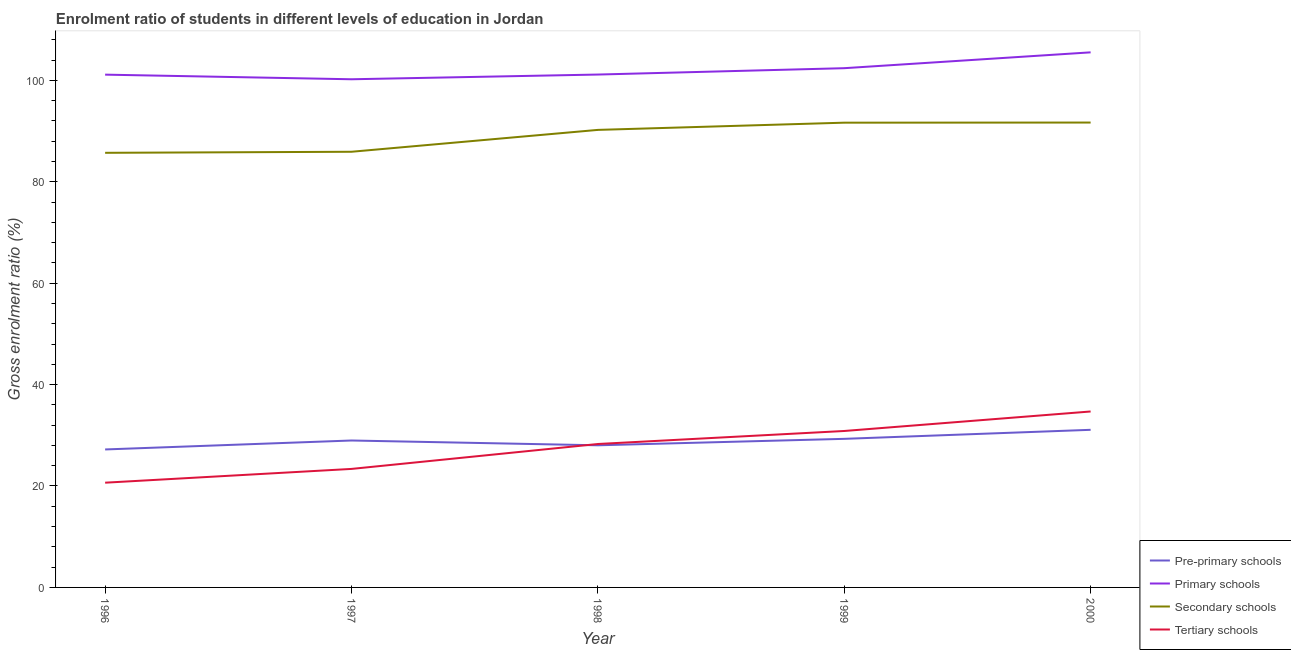How many different coloured lines are there?
Your response must be concise. 4. What is the gross enrolment ratio in tertiary schools in 1999?
Offer a terse response. 30.85. Across all years, what is the maximum gross enrolment ratio in primary schools?
Ensure brevity in your answer.  105.51. Across all years, what is the minimum gross enrolment ratio in tertiary schools?
Ensure brevity in your answer.  20.65. What is the total gross enrolment ratio in pre-primary schools in the graph?
Your answer should be compact. 144.58. What is the difference between the gross enrolment ratio in secondary schools in 1997 and that in 1999?
Give a very brief answer. -5.74. What is the difference between the gross enrolment ratio in primary schools in 1997 and the gross enrolment ratio in tertiary schools in 1998?
Your response must be concise. 71.92. What is the average gross enrolment ratio in primary schools per year?
Your response must be concise. 102.07. In the year 1996, what is the difference between the gross enrolment ratio in tertiary schools and gross enrolment ratio in primary schools?
Offer a very short reply. -80.46. What is the ratio of the gross enrolment ratio in tertiary schools in 1996 to that in 1997?
Your answer should be compact. 0.88. Is the difference between the gross enrolment ratio in tertiary schools in 1998 and 2000 greater than the difference between the gross enrolment ratio in pre-primary schools in 1998 and 2000?
Your response must be concise. No. What is the difference between the highest and the second highest gross enrolment ratio in tertiary schools?
Offer a very short reply. 3.85. What is the difference between the highest and the lowest gross enrolment ratio in pre-primary schools?
Provide a succinct answer. 3.87. Is the sum of the gross enrolment ratio in primary schools in 1998 and 2000 greater than the maximum gross enrolment ratio in tertiary schools across all years?
Your answer should be very brief. Yes. Is it the case that in every year, the sum of the gross enrolment ratio in pre-primary schools and gross enrolment ratio in primary schools is greater than the gross enrolment ratio in secondary schools?
Give a very brief answer. Yes. Is the gross enrolment ratio in primary schools strictly less than the gross enrolment ratio in secondary schools over the years?
Make the answer very short. No. How many lines are there?
Give a very brief answer. 4. How many years are there in the graph?
Provide a short and direct response. 5. How many legend labels are there?
Your answer should be very brief. 4. What is the title of the graph?
Your answer should be very brief. Enrolment ratio of students in different levels of education in Jordan. Does "Primary schools" appear as one of the legend labels in the graph?
Ensure brevity in your answer.  Yes. What is the Gross enrolment ratio (%) of Pre-primary schools in 1996?
Provide a short and direct response. 27.21. What is the Gross enrolment ratio (%) of Primary schools in 1996?
Keep it short and to the point. 101.11. What is the Gross enrolment ratio (%) in Secondary schools in 1996?
Ensure brevity in your answer.  85.7. What is the Gross enrolment ratio (%) of Tertiary schools in 1996?
Your answer should be very brief. 20.65. What is the Gross enrolment ratio (%) in Pre-primary schools in 1997?
Offer a very short reply. 28.97. What is the Gross enrolment ratio (%) of Primary schools in 1997?
Your answer should be compact. 100.2. What is the Gross enrolment ratio (%) of Secondary schools in 1997?
Make the answer very short. 85.91. What is the Gross enrolment ratio (%) of Tertiary schools in 1997?
Provide a succinct answer. 23.37. What is the Gross enrolment ratio (%) of Pre-primary schools in 1998?
Your answer should be compact. 28.03. What is the Gross enrolment ratio (%) of Primary schools in 1998?
Give a very brief answer. 101.13. What is the Gross enrolment ratio (%) of Secondary schools in 1998?
Your answer should be very brief. 90.22. What is the Gross enrolment ratio (%) of Tertiary schools in 1998?
Give a very brief answer. 28.28. What is the Gross enrolment ratio (%) of Pre-primary schools in 1999?
Your answer should be very brief. 29.3. What is the Gross enrolment ratio (%) of Primary schools in 1999?
Offer a terse response. 102.39. What is the Gross enrolment ratio (%) in Secondary schools in 1999?
Your answer should be very brief. 91.64. What is the Gross enrolment ratio (%) of Tertiary schools in 1999?
Your answer should be very brief. 30.85. What is the Gross enrolment ratio (%) in Pre-primary schools in 2000?
Your answer should be very brief. 31.08. What is the Gross enrolment ratio (%) in Primary schools in 2000?
Give a very brief answer. 105.51. What is the Gross enrolment ratio (%) in Secondary schools in 2000?
Your response must be concise. 91.67. What is the Gross enrolment ratio (%) in Tertiary schools in 2000?
Provide a short and direct response. 34.69. Across all years, what is the maximum Gross enrolment ratio (%) in Pre-primary schools?
Offer a very short reply. 31.08. Across all years, what is the maximum Gross enrolment ratio (%) of Primary schools?
Offer a very short reply. 105.51. Across all years, what is the maximum Gross enrolment ratio (%) in Secondary schools?
Give a very brief answer. 91.67. Across all years, what is the maximum Gross enrolment ratio (%) of Tertiary schools?
Your answer should be compact. 34.69. Across all years, what is the minimum Gross enrolment ratio (%) of Pre-primary schools?
Ensure brevity in your answer.  27.21. Across all years, what is the minimum Gross enrolment ratio (%) in Primary schools?
Offer a very short reply. 100.2. Across all years, what is the minimum Gross enrolment ratio (%) of Secondary schools?
Your answer should be very brief. 85.7. Across all years, what is the minimum Gross enrolment ratio (%) in Tertiary schools?
Make the answer very short. 20.65. What is the total Gross enrolment ratio (%) of Pre-primary schools in the graph?
Your answer should be compact. 144.58. What is the total Gross enrolment ratio (%) of Primary schools in the graph?
Ensure brevity in your answer.  510.35. What is the total Gross enrolment ratio (%) in Secondary schools in the graph?
Offer a terse response. 445.14. What is the total Gross enrolment ratio (%) of Tertiary schools in the graph?
Offer a terse response. 137.84. What is the difference between the Gross enrolment ratio (%) of Pre-primary schools in 1996 and that in 1997?
Give a very brief answer. -1.77. What is the difference between the Gross enrolment ratio (%) in Primary schools in 1996 and that in 1997?
Provide a succinct answer. 0.91. What is the difference between the Gross enrolment ratio (%) in Secondary schools in 1996 and that in 1997?
Offer a terse response. -0.21. What is the difference between the Gross enrolment ratio (%) of Tertiary schools in 1996 and that in 1997?
Make the answer very short. -2.72. What is the difference between the Gross enrolment ratio (%) of Pre-primary schools in 1996 and that in 1998?
Ensure brevity in your answer.  -0.82. What is the difference between the Gross enrolment ratio (%) in Primary schools in 1996 and that in 1998?
Offer a very short reply. -0.02. What is the difference between the Gross enrolment ratio (%) of Secondary schools in 1996 and that in 1998?
Keep it short and to the point. -4.52. What is the difference between the Gross enrolment ratio (%) in Tertiary schools in 1996 and that in 1998?
Provide a succinct answer. -7.63. What is the difference between the Gross enrolment ratio (%) of Pre-primary schools in 1996 and that in 1999?
Make the answer very short. -2.09. What is the difference between the Gross enrolment ratio (%) of Primary schools in 1996 and that in 1999?
Keep it short and to the point. -1.27. What is the difference between the Gross enrolment ratio (%) in Secondary schools in 1996 and that in 1999?
Offer a very short reply. -5.94. What is the difference between the Gross enrolment ratio (%) in Tertiary schools in 1996 and that in 1999?
Keep it short and to the point. -10.2. What is the difference between the Gross enrolment ratio (%) in Pre-primary schools in 1996 and that in 2000?
Your answer should be compact. -3.87. What is the difference between the Gross enrolment ratio (%) in Primary schools in 1996 and that in 2000?
Offer a very short reply. -4.4. What is the difference between the Gross enrolment ratio (%) in Secondary schools in 1996 and that in 2000?
Provide a short and direct response. -5.97. What is the difference between the Gross enrolment ratio (%) in Tertiary schools in 1996 and that in 2000?
Keep it short and to the point. -14.04. What is the difference between the Gross enrolment ratio (%) in Pre-primary schools in 1997 and that in 1998?
Your answer should be very brief. 0.95. What is the difference between the Gross enrolment ratio (%) in Primary schools in 1997 and that in 1998?
Provide a short and direct response. -0.93. What is the difference between the Gross enrolment ratio (%) in Secondary schools in 1997 and that in 1998?
Ensure brevity in your answer.  -4.31. What is the difference between the Gross enrolment ratio (%) in Tertiary schools in 1997 and that in 1998?
Your answer should be very brief. -4.91. What is the difference between the Gross enrolment ratio (%) in Pre-primary schools in 1997 and that in 1999?
Provide a short and direct response. -0.32. What is the difference between the Gross enrolment ratio (%) of Primary schools in 1997 and that in 1999?
Your answer should be very brief. -2.18. What is the difference between the Gross enrolment ratio (%) in Secondary schools in 1997 and that in 1999?
Provide a succinct answer. -5.74. What is the difference between the Gross enrolment ratio (%) of Tertiary schools in 1997 and that in 1999?
Keep it short and to the point. -7.48. What is the difference between the Gross enrolment ratio (%) of Pre-primary schools in 1997 and that in 2000?
Make the answer very short. -2.11. What is the difference between the Gross enrolment ratio (%) of Primary schools in 1997 and that in 2000?
Give a very brief answer. -5.31. What is the difference between the Gross enrolment ratio (%) in Secondary schools in 1997 and that in 2000?
Your response must be concise. -5.76. What is the difference between the Gross enrolment ratio (%) of Tertiary schools in 1997 and that in 2000?
Your answer should be very brief. -11.32. What is the difference between the Gross enrolment ratio (%) of Pre-primary schools in 1998 and that in 1999?
Your answer should be compact. -1.27. What is the difference between the Gross enrolment ratio (%) of Primary schools in 1998 and that in 1999?
Keep it short and to the point. -1.25. What is the difference between the Gross enrolment ratio (%) of Secondary schools in 1998 and that in 1999?
Your response must be concise. -1.42. What is the difference between the Gross enrolment ratio (%) of Tertiary schools in 1998 and that in 1999?
Make the answer very short. -2.57. What is the difference between the Gross enrolment ratio (%) in Pre-primary schools in 1998 and that in 2000?
Ensure brevity in your answer.  -3.05. What is the difference between the Gross enrolment ratio (%) of Primary schools in 1998 and that in 2000?
Give a very brief answer. -4.38. What is the difference between the Gross enrolment ratio (%) in Secondary schools in 1998 and that in 2000?
Your answer should be very brief. -1.45. What is the difference between the Gross enrolment ratio (%) in Tertiary schools in 1998 and that in 2000?
Your answer should be very brief. -6.41. What is the difference between the Gross enrolment ratio (%) of Pre-primary schools in 1999 and that in 2000?
Make the answer very short. -1.78. What is the difference between the Gross enrolment ratio (%) in Primary schools in 1999 and that in 2000?
Give a very brief answer. -3.12. What is the difference between the Gross enrolment ratio (%) in Secondary schools in 1999 and that in 2000?
Keep it short and to the point. -0.02. What is the difference between the Gross enrolment ratio (%) in Tertiary schools in 1999 and that in 2000?
Make the answer very short. -3.85. What is the difference between the Gross enrolment ratio (%) of Pre-primary schools in 1996 and the Gross enrolment ratio (%) of Primary schools in 1997?
Provide a short and direct response. -73. What is the difference between the Gross enrolment ratio (%) in Pre-primary schools in 1996 and the Gross enrolment ratio (%) in Secondary schools in 1997?
Your response must be concise. -58.7. What is the difference between the Gross enrolment ratio (%) in Pre-primary schools in 1996 and the Gross enrolment ratio (%) in Tertiary schools in 1997?
Provide a short and direct response. 3.84. What is the difference between the Gross enrolment ratio (%) in Primary schools in 1996 and the Gross enrolment ratio (%) in Secondary schools in 1997?
Your answer should be compact. 15.21. What is the difference between the Gross enrolment ratio (%) of Primary schools in 1996 and the Gross enrolment ratio (%) of Tertiary schools in 1997?
Your response must be concise. 77.74. What is the difference between the Gross enrolment ratio (%) in Secondary schools in 1996 and the Gross enrolment ratio (%) in Tertiary schools in 1997?
Offer a very short reply. 62.33. What is the difference between the Gross enrolment ratio (%) in Pre-primary schools in 1996 and the Gross enrolment ratio (%) in Primary schools in 1998?
Your response must be concise. -73.93. What is the difference between the Gross enrolment ratio (%) in Pre-primary schools in 1996 and the Gross enrolment ratio (%) in Secondary schools in 1998?
Ensure brevity in your answer.  -63.01. What is the difference between the Gross enrolment ratio (%) in Pre-primary schools in 1996 and the Gross enrolment ratio (%) in Tertiary schools in 1998?
Your answer should be very brief. -1.07. What is the difference between the Gross enrolment ratio (%) of Primary schools in 1996 and the Gross enrolment ratio (%) of Secondary schools in 1998?
Your answer should be compact. 10.89. What is the difference between the Gross enrolment ratio (%) in Primary schools in 1996 and the Gross enrolment ratio (%) in Tertiary schools in 1998?
Keep it short and to the point. 72.83. What is the difference between the Gross enrolment ratio (%) of Secondary schools in 1996 and the Gross enrolment ratio (%) of Tertiary schools in 1998?
Your response must be concise. 57.42. What is the difference between the Gross enrolment ratio (%) in Pre-primary schools in 1996 and the Gross enrolment ratio (%) in Primary schools in 1999?
Provide a short and direct response. -75.18. What is the difference between the Gross enrolment ratio (%) of Pre-primary schools in 1996 and the Gross enrolment ratio (%) of Secondary schools in 1999?
Ensure brevity in your answer.  -64.44. What is the difference between the Gross enrolment ratio (%) of Pre-primary schools in 1996 and the Gross enrolment ratio (%) of Tertiary schools in 1999?
Keep it short and to the point. -3.64. What is the difference between the Gross enrolment ratio (%) of Primary schools in 1996 and the Gross enrolment ratio (%) of Secondary schools in 1999?
Give a very brief answer. 9.47. What is the difference between the Gross enrolment ratio (%) in Primary schools in 1996 and the Gross enrolment ratio (%) in Tertiary schools in 1999?
Keep it short and to the point. 70.27. What is the difference between the Gross enrolment ratio (%) in Secondary schools in 1996 and the Gross enrolment ratio (%) in Tertiary schools in 1999?
Offer a very short reply. 54.85. What is the difference between the Gross enrolment ratio (%) in Pre-primary schools in 1996 and the Gross enrolment ratio (%) in Primary schools in 2000?
Make the answer very short. -78.3. What is the difference between the Gross enrolment ratio (%) in Pre-primary schools in 1996 and the Gross enrolment ratio (%) in Secondary schools in 2000?
Give a very brief answer. -64.46. What is the difference between the Gross enrolment ratio (%) of Pre-primary schools in 1996 and the Gross enrolment ratio (%) of Tertiary schools in 2000?
Provide a succinct answer. -7.49. What is the difference between the Gross enrolment ratio (%) in Primary schools in 1996 and the Gross enrolment ratio (%) in Secondary schools in 2000?
Make the answer very short. 9.45. What is the difference between the Gross enrolment ratio (%) in Primary schools in 1996 and the Gross enrolment ratio (%) in Tertiary schools in 2000?
Offer a very short reply. 66.42. What is the difference between the Gross enrolment ratio (%) of Secondary schools in 1996 and the Gross enrolment ratio (%) of Tertiary schools in 2000?
Give a very brief answer. 51.01. What is the difference between the Gross enrolment ratio (%) in Pre-primary schools in 1997 and the Gross enrolment ratio (%) in Primary schools in 1998?
Ensure brevity in your answer.  -72.16. What is the difference between the Gross enrolment ratio (%) of Pre-primary schools in 1997 and the Gross enrolment ratio (%) of Secondary schools in 1998?
Provide a short and direct response. -61.25. What is the difference between the Gross enrolment ratio (%) in Pre-primary schools in 1997 and the Gross enrolment ratio (%) in Tertiary schools in 1998?
Make the answer very short. 0.69. What is the difference between the Gross enrolment ratio (%) of Primary schools in 1997 and the Gross enrolment ratio (%) of Secondary schools in 1998?
Your answer should be compact. 9.98. What is the difference between the Gross enrolment ratio (%) in Primary schools in 1997 and the Gross enrolment ratio (%) in Tertiary schools in 1998?
Your response must be concise. 71.92. What is the difference between the Gross enrolment ratio (%) of Secondary schools in 1997 and the Gross enrolment ratio (%) of Tertiary schools in 1998?
Provide a succinct answer. 57.63. What is the difference between the Gross enrolment ratio (%) of Pre-primary schools in 1997 and the Gross enrolment ratio (%) of Primary schools in 1999?
Make the answer very short. -73.41. What is the difference between the Gross enrolment ratio (%) in Pre-primary schools in 1997 and the Gross enrolment ratio (%) in Secondary schools in 1999?
Make the answer very short. -62.67. What is the difference between the Gross enrolment ratio (%) in Pre-primary schools in 1997 and the Gross enrolment ratio (%) in Tertiary schools in 1999?
Your answer should be very brief. -1.87. What is the difference between the Gross enrolment ratio (%) in Primary schools in 1997 and the Gross enrolment ratio (%) in Secondary schools in 1999?
Offer a terse response. 8.56. What is the difference between the Gross enrolment ratio (%) in Primary schools in 1997 and the Gross enrolment ratio (%) in Tertiary schools in 1999?
Offer a terse response. 69.35. What is the difference between the Gross enrolment ratio (%) in Secondary schools in 1997 and the Gross enrolment ratio (%) in Tertiary schools in 1999?
Offer a terse response. 55.06. What is the difference between the Gross enrolment ratio (%) of Pre-primary schools in 1997 and the Gross enrolment ratio (%) of Primary schools in 2000?
Ensure brevity in your answer.  -76.54. What is the difference between the Gross enrolment ratio (%) of Pre-primary schools in 1997 and the Gross enrolment ratio (%) of Secondary schools in 2000?
Keep it short and to the point. -62.69. What is the difference between the Gross enrolment ratio (%) in Pre-primary schools in 1997 and the Gross enrolment ratio (%) in Tertiary schools in 2000?
Make the answer very short. -5.72. What is the difference between the Gross enrolment ratio (%) in Primary schools in 1997 and the Gross enrolment ratio (%) in Secondary schools in 2000?
Your response must be concise. 8.54. What is the difference between the Gross enrolment ratio (%) in Primary schools in 1997 and the Gross enrolment ratio (%) in Tertiary schools in 2000?
Provide a short and direct response. 65.51. What is the difference between the Gross enrolment ratio (%) of Secondary schools in 1997 and the Gross enrolment ratio (%) of Tertiary schools in 2000?
Offer a terse response. 51.21. What is the difference between the Gross enrolment ratio (%) of Pre-primary schools in 1998 and the Gross enrolment ratio (%) of Primary schools in 1999?
Offer a very short reply. -74.36. What is the difference between the Gross enrolment ratio (%) of Pre-primary schools in 1998 and the Gross enrolment ratio (%) of Secondary schools in 1999?
Your response must be concise. -63.62. What is the difference between the Gross enrolment ratio (%) of Pre-primary schools in 1998 and the Gross enrolment ratio (%) of Tertiary schools in 1999?
Keep it short and to the point. -2.82. What is the difference between the Gross enrolment ratio (%) in Primary schools in 1998 and the Gross enrolment ratio (%) in Secondary schools in 1999?
Offer a terse response. 9.49. What is the difference between the Gross enrolment ratio (%) in Primary schools in 1998 and the Gross enrolment ratio (%) in Tertiary schools in 1999?
Keep it short and to the point. 70.29. What is the difference between the Gross enrolment ratio (%) of Secondary schools in 1998 and the Gross enrolment ratio (%) of Tertiary schools in 1999?
Ensure brevity in your answer.  59.37. What is the difference between the Gross enrolment ratio (%) in Pre-primary schools in 1998 and the Gross enrolment ratio (%) in Primary schools in 2000?
Your answer should be very brief. -77.48. What is the difference between the Gross enrolment ratio (%) of Pre-primary schools in 1998 and the Gross enrolment ratio (%) of Secondary schools in 2000?
Ensure brevity in your answer.  -63.64. What is the difference between the Gross enrolment ratio (%) of Pre-primary schools in 1998 and the Gross enrolment ratio (%) of Tertiary schools in 2000?
Your answer should be compact. -6.67. What is the difference between the Gross enrolment ratio (%) in Primary schools in 1998 and the Gross enrolment ratio (%) in Secondary schools in 2000?
Ensure brevity in your answer.  9.47. What is the difference between the Gross enrolment ratio (%) in Primary schools in 1998 and the Gross enrolment ratio (%) in Tertiary schools in 2000?
Keep it short and to the point. 66.44. What is the difference between the Gross enrolment ratio (%) of Secondary schools in 1998 and the Gross enrolment ratio (%) of Tertiary schools in 2000?
Keep it short and to the point. 55.53. What is the difference between the Gross enrolment ratio (%) in Pre-primary schools in 1999 and the Gross enrolment ratio (%) in Primary schools in 2000?
Your answer should be very brief. -76.21. What is the difference between the Gross enrolment ratio (%) of Pre-primary schools in 1999 and the Gross enrolment ratio (%) of Secondary schools in 2000?
Offer a terse response. -62.37. What is the difference between the Gross enrolment ratio (%) of Pre-primary schools in 1999 and the Gross enrolment ratio (%) of Tertiary schools in 2000?
Offer a very short reply. -5.4. What is the difference between the Gross enrolment ratio (%) of Primary schools in 1999 and the Gross enrolment ratio (%) of Secondary schools in 2000?
Offer a very short reply. 10.72. What is the difference between the Gross enrolment ratio (%) in Primary schools in 1999 and the Gross enrolment ratio (%) in Tertiary schools in 2000?
Make the answer very short. 67.69. What is the difference between the Gross enrolment ratio (%) in Secondary schools in 1999 and the Gross enrolment ratio (%) in Tertiary schools in 2000?
Your answer should be very brief. 56.95. What is the average Gross enrolment ratio (%) of Pre-primary schools per year?
Keep it short and to the point. 28.92. What is the average Gross enrolment ratio (%) of Primary schools per year?
Make the answer very short. 102.07. What is the average Gross enrolment ratio (%) in Secondary schools per year?
Ensure brevity in your answer.  89.03. What is the average Gross enrolment ratio (%) of Tertiary schools per year?
Offer a very short reply. 27.57. In the year 1996, what is the difference between the Gross enrolment ratio (%) in Pre-primary schools and Gross enrolment ratio (%) in Primary schools?
Make the answer very short. -73.91. In the year 1996, what is the difference between the Gross enrolment ratio (%) of Pre-primary schools and Gross enrolment ratio (%) of Secondary schools?
Provide a short and direct response. -58.49. In the year 1996, what is the difference between the Gross enrolment ratio (%) in Pre-primary schools and Gross enrolment ratio (%) in Tertiary schools?
Provide a succinct answer. 6.55. In the year 1996, what is the difference between the Gross enrolment ratio (%) of Primary schools and Gross enrolment ratio (%) of Secondary schools?
Ensure brevity in your answer.  15.41. In the year 1996, what is the difference between the Gross enrolment ratio (%) in Primary schools and Gross enrolment ratio (%) in Tertiary schools?
Make the answer very short. 80.46. In the year 1996, what is the difference between the Gross enrolment ratio (%) in Secondary schools and Gross enrolment ratio (%) in Tertiary schools?
Your response must be concise. 65.05. In the year 1997, what is the difference between the Gross enrolment ratio (%) of Pre-primary schools and Gross enrolment ratio (%) of Primary schools?
Offer a very short reply. -71.23. In the year 1997, what is the difference between the Gross enrolment ratio (%) of Pre-primary schools and Gross enrolment ratio (%) of Secondary schools?
Provide a short and direct response. -56.93. In the year 1997, what is the difference between the Gross enrolment ratio (%) in Pre-primary schools and Gross enrolment ratio (%) in Tertiary schools?
Provide a succinct answer. 5.6. In the year 1997, what is the difference between the Gross enrolment ratio (%) in Primary schools and Gross enrolment ratio (%) in Secondary schools?
Offer a terse response. 14.3. In the year 1997, what is the difference between the Gross enrolment ratio (%) of Primary schools and Gross enrolment ratio (%) of Tertiary schools?
Offer a very short reply. 76.83. In the year 1997, what is the difference between the Gross enrolment ratio (%) in Secondary schools and Gross enrolment ratio (%) in Tertiary schools?
Your answer should be very brief. 62.54. In the year 1998, what is the difference between the Gross enrolment ratio (%) in Pre-primary schools and Gross enrolment ratio (%) in Primary schools?
Offer a terse response. -73.11. In the year 1998, what is the difference between the Gross enrolment ratio (%) of Pre-primary schools and Gross enrolment ratio (%) of Secondary schools?
Keep it short and to the point. -62.19. In the year 1998, what is the difference between the Gross enrolment ratio (%) of Pre-primary schools and Gross enrolment ratio (%) of Tertiary schools?
Keep it short and to the point. -0.25. In the year 1998, what is the difference between the Gross enrolment ratio (%) in Primary schools and Gross enrolment ratio (%) in Secondary schools?
Ensure brevity in your answer.  10.91. In the year 1998, what is the difference between the Gross enrolment ratio (%) of Primary schools and Gross enrolment ratio (%) of Tertiary schools?
Offer a terse response. 72.85. In the year 1998, what is the difference between the Gross enrolment ratio (%) of Secondary schools and Gross enrolment ratio (%) of Tertiary schools?
Your answer should be compact. 61.94. In the year 1999, what is the difference between the Gross enrolment ratio (%) in Pre-primary schools and Gross enrolment ratio (%) in Primary schools?
Your response must be concise. -73.09. In the year 1999, what is the difference between the Gross enrolment ratio (%) of Pre-primary schools and Gross enrolment ratio (%) of Secondary schools?
Ensure brevity in your answer.  -62.35. In the year 1999, what is the difference between the Gross enrolment ratio (%) of Pre-primary schools and Gross enrolment ratio (%) of Tertiary schools?
Your response must be concise. -1.55. In the year 1999, what is the difference between the Gross enrolment ratio (%) of Primary schools and Gross enrolment ratio (%) of Secondary schools?
Your answer should be very brief. 10.74. In the year 1999, what is the difference between the Gross enrolment ratio (%) of Primary schools and Gross enrolment ratio (%) of Tertiary schools?
Provide a short and direct response. 71.54. In the year 1999, what is the difference between the Gross enrolment ratio (%) in Secondary schools and Gross enrolment ratio (%) in Tertiary schools?
Give a very brief answer. 60.8. In the year 2000, what is the difference between the Gross enrolment ratio (%) in Pre-primary schools and Gross enrolment ratio (%) in Primary schools?
Your answer should be very brief. -74.43. In the year 2000, what is the difference between the Gross enrolment ratio (%) of Pre-primary schools and Gross enrolment ratio (%) of Secondary schools?
Your answer should be very brief. -60.59. In the year 2000, what is the difference between the Gross enrolment ratio (%) of Pre-primary schools and Gross enrolment ratio (%) of Tertiary schools?
Make the answer very short. -3.61. In the year 2000, what is the difference between the Gross enrolment ratio (%) of Primary schools and Gross enrolment ratio (%) of Secondary schools?
Offer a very short reply. 13.84. In the year 2000, what is the difference between the Gross enrolment ratio (%) in Primary schools and Gross enrolment ratio (%) in Tertiary schools?
Keep it short and to the point. 70.82. In the year 2000, what is the difference between the Gross enrolment ratio (%) in Secondary schools and Gross enrolment ratio (%) in Tertiary schools?
Make the answer very short. 56.97. What is the ratio of the Gross enrolment ratio (%) of Pre-primary schools in 1996 to that in 1997?
Offer a terse response. 0.94. What is the ratio of the Gross enrolment ratio (%) in Primary schools in 1996 to that in 1997?
Your answer should be compact. 1.01. What is the ratio of the Gross enrolment ratio (%) in Tertiary schools in 1996 to that in 1997?
Your answer should be compact. 0.88. What is the ratio of the Gross enrolment ratio (%) of Pre-primary schools in 1996 to that in 1998?
Offer a very short reply. 0.97. What is the ratio of the Gross enrolment ratio (%) of Secondary schools in 1996 to that in 1998?
Keep it short and to the point. 0.95. What is the ratio of the Gross enrolment ratio (%) of Tertiary schools in 1996 to that in 1998?
Your response must be concise. 0.73. What is the ratio of the Gross enrolment ratio (%) of Primary schools in 1996 to that in 1999?
Give a very brief answer. 0.99. What is the ratio of the Gross enrolment ratio (%) in Secondary schools in 1996 to that in 1999?
Keep it short and to the point. 0.94. What is the ratio of the Gross enrolment ratio (%) of Tertiary schools in 1996 to that in 1999?
Provide a succinct answer. 0.67. What is the ratio of the Gross enrolment ratio (%) of Pre-primary schools in 1996 to that in 2000?
Your answer should be very brief. 0.88. What is the ratio of the Gross enrolment ratio (%) of Secondary schools in 1996 to that in 2000?
Your answer should be compact. 0.93. What is the ratio of the Gross enrolment ratio (%) in Tertiary schools in 1996 to that in 2000?
Offer a terse response. 0.6. What is the ratio of the Gross enrolment ratio (%) in Pre-primary schools in 1997 to that in 1998?
Offer a very short reply. 1.03. What is the ratio of the Gross enrolment ratio (%) of Primary schools in 1997 to that in 1998?
Your response must be concise. 0.99. What is the ratio of the Gross enrolment ratio (%) in Secondary schools in 1997 to that in 1998?
Provide a succinct answer. 0.95. What is the ratio of the Gross enrolment ratio (%) of Tertiary schools in 1997 to that in 1998?
Provide a succinct answer. 0.83. What is the ratio of the Gross enrolment ratio (%) of Pre-primary schools in 1997 to that in 1999?
Offer a terse response. 0.99. What is the ratio of the Gross enrolment ratio (%) of Primary schools in 1997 to that in 1999?
Offer a terse response. 0.98. What is the ratio of the Gross enrolment ratio (%) in Secondary schools in 1997 to that in 1999?
Offer a very short reply. 0.94. What is the ratio of the Gross enrolment ratio (%) of Tertiary schools in 1997 to that in 1999?
Your response must be concise. 0.76. What is the ratio of the Gross enrolment ratio (%) in Pre-primary schools in 1997 to that in 2000?
Your response must be concise. 0.93. What is the ratio of the Gross enrolment ratio (%) of Primary schools in 1997 to that in 2000?
Your answer should be very brief. 0.95. What is the ratio of the Gross enrolment ratio (%) of Secondary schools in 1997 to that in 2000?
Your answer should be very brief. 0.94. What is the ratio of the Gross enrolment ratio (%) in Tertiary schools in 1997 to that in 2000?
Ensure brevity in your answer.  0.67. What is the ratio of the Gross enrolment ratio (%) of Pre-primary schools in 1998 to that in 1999?
Offer a very short reply. 0.96. What is the ratio of the Gross enrolment ratio (%) in Secondary schools in 1998 to that in 1999?
Your response must be concise. 0.98. What is the ratio of the Gross enrolment ratio (%) of Tertiary schools in 1998 to that in 1999?
Provide a short and direct response. 0.92. What is the ratio of the Gross enrolment ratio (%) of Pre-primary schools in 1998 to that in 2000?
Your answer should be compact. 0.9. What is the ratio of the Gross enrolment ratio (%) of Primary schools in 1998 to that in 2000?
Make the answer very short. 0.96. What is the ratio of the Gross enrolment ratio (%) in Secondary schools in 1998 to that in 2000?
Provide a succinct answer. 0.98. What is the ratio of the Gross enrolment ratio (%) of Tertiary schools in 1998 to that in 2000?
Provide a short and direct response. 0.82. What is the ratio of the Gross enrolment ratio (%) in Pre-primary schools in 1999 to that in 2000?
Provide a succinct answer. 0.94. What is the ratio of the Gross enrolment ratio (%) of Primary schools in 1999 to that in 2000?
Provide a succinct answer. 0.97. What is the ratio of the Gross enrolment ratio (%) in Secondary schools in 1999 to that in 2000?
Ensure brevity in your answer.  1. What is the ratio of the Gross enrolment ratio (%) in Tertiary schools in 1999 to that in 2000?
Keep it short and to the point. 0.89. What is the difference between the highest and the second highest Gross enrolment ratio (%) in Pre-primary schools?
Offer a very short reply. 1.78. What is the difference between the highest and the second highest Gross enrolment ratio (%) of Primary schools?
Provide a succinct answer. 3.12. What is the difference between the highest and the second highest Gross enrolment ratio (%) in Secondary schools?
Provide a short and direct response. 0.02. What is the difference between the highest and the second highest Gross enrolment ratio (%) of Tertiary schools?
Your response must be concise. 3.85. What is the difference between the highest and the lowest Gross enrolment ratio (%) of Pre-primary schools?
Your response must be concise. 3.87. What is the difference between the highest and the lowest Gross enrolment ratio (%) of Primary schools?
Make the answer very short. 5.31. What is the difference between the highest and the lowest Gross enrolment ratio (%) in Secondary schools?
Provide a short and direct response. 5.97. What is the difference between the highest and the lowest Gross enrolment ratio (%) in Tertiary schools?
Provide a succinct answer. 14.04. 